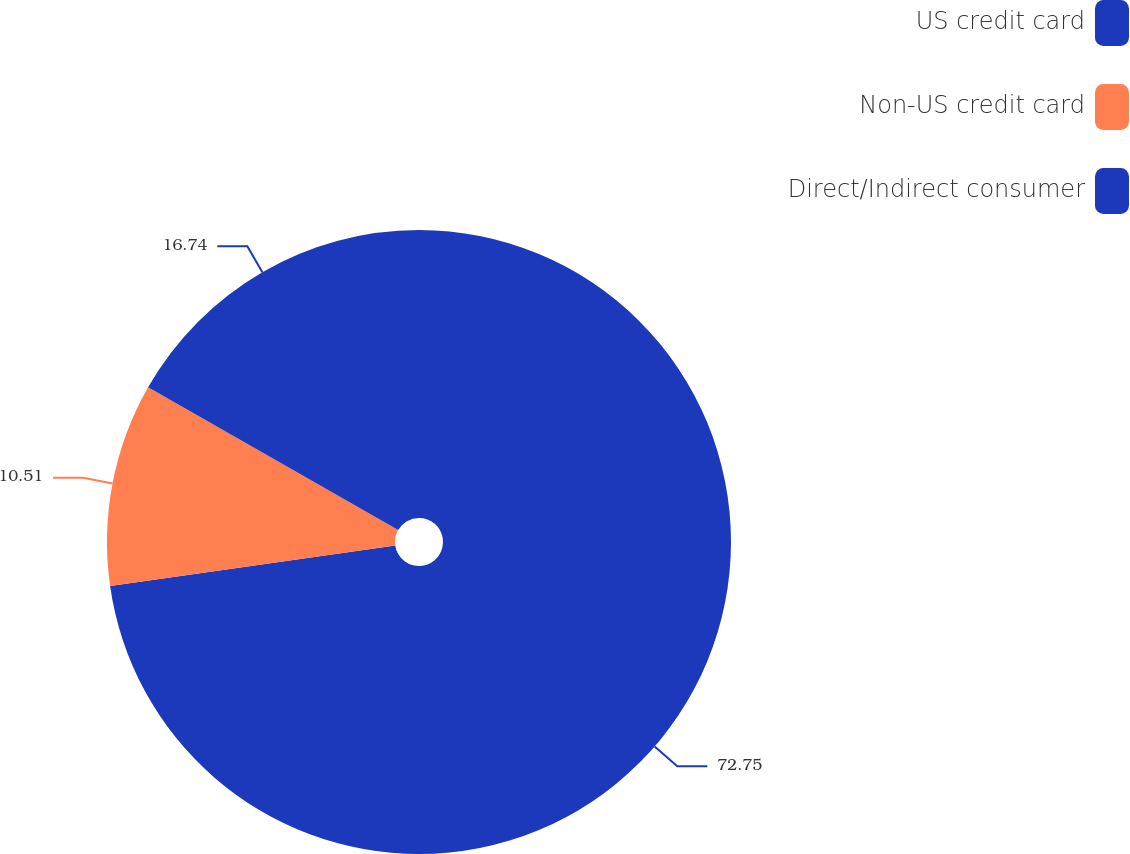<chart> <loc_0><loc_0><loc_500><loc_500><pie_chart><fcel>US credit card<fcel>Non-US credit card<fcel>Direct/Indirect consumer<nl><fcel>72.75%<fcel>10.51%<fcel>16.74%<nl></chart> 